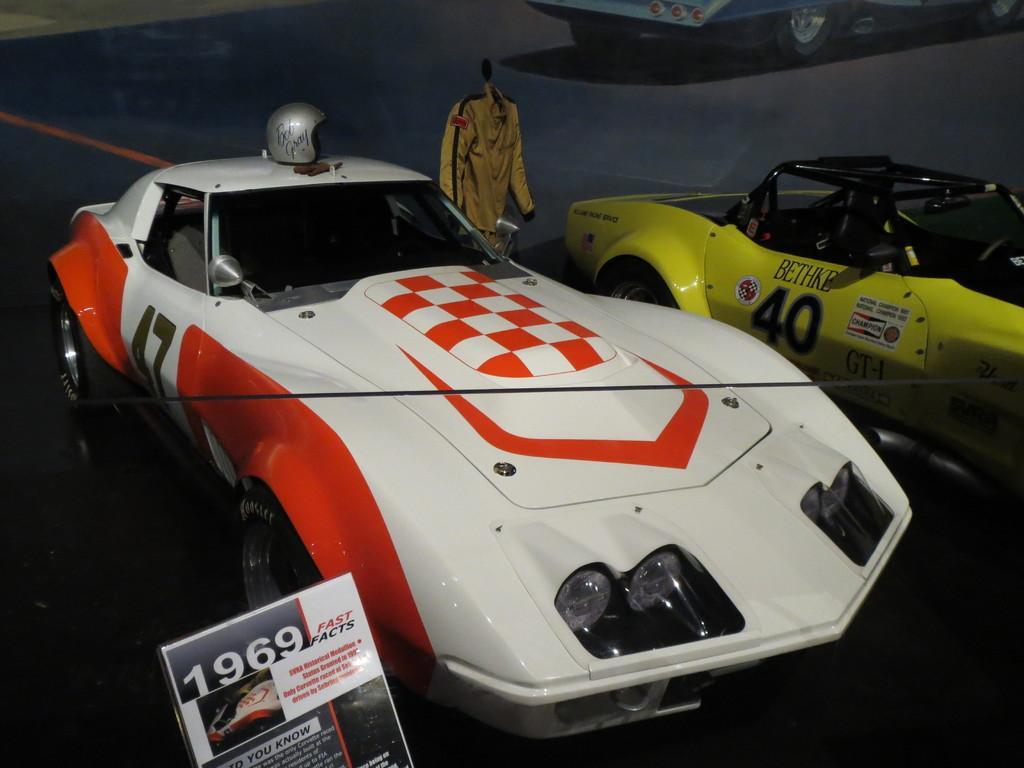Describe this image in one or two sentences. In the picture I can see two cars on the road and there is a helmet at the top of the car. I can see the banner board on the bottom left side. There is a race suit at the top of the image. I can see another car on the top right side. 